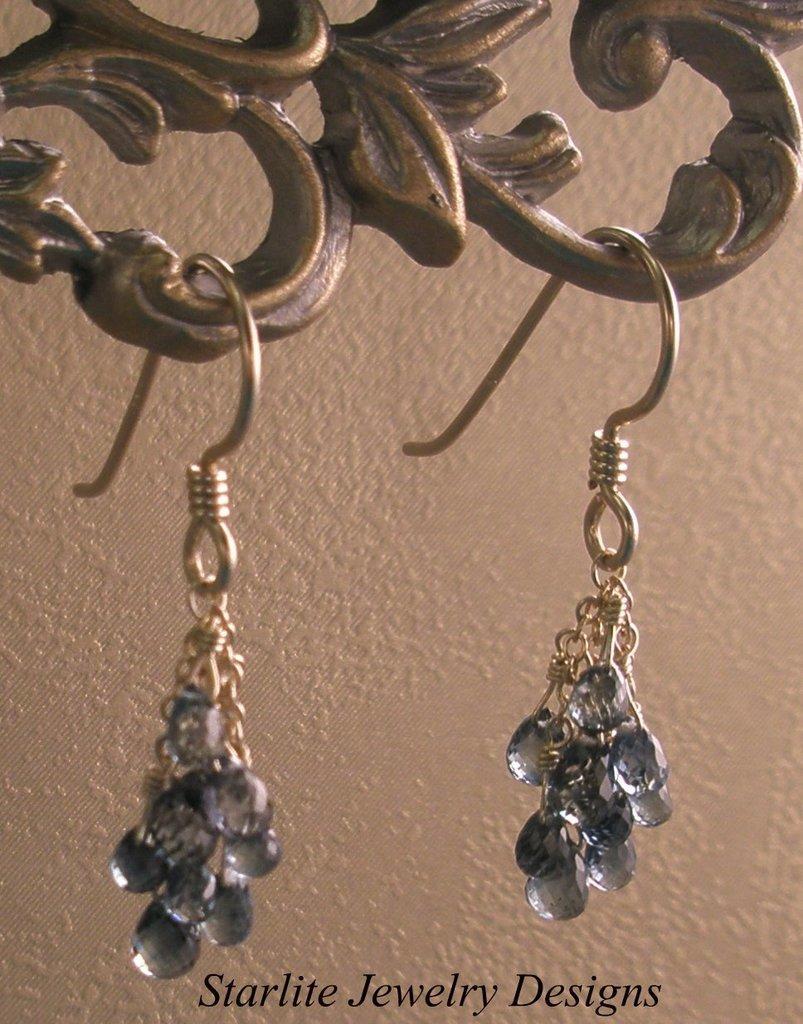Can you describe this image briefly? In this image I can see two earrings are hanging to a metal object. In the background there is a wall. At the bottom there is some edited text. 